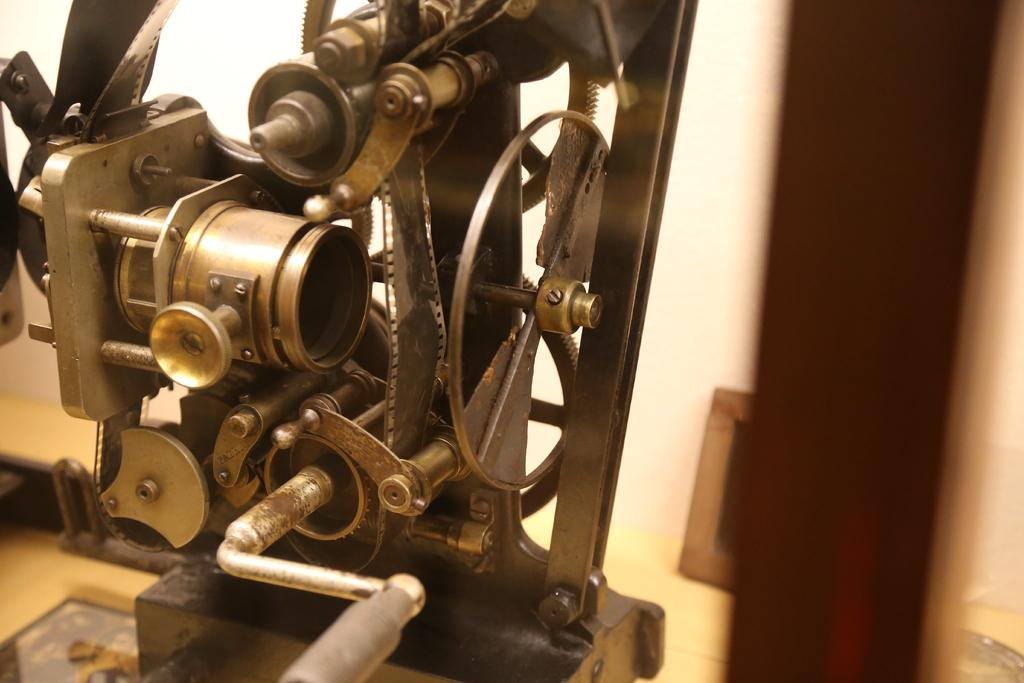What type of movie projector is in the image? There is a vintage reel to reel movie projector in the image. What is inside the projector? The projector has a reel, a wheel, and a handle inside, along with other visible parts. What is the condition of the background in the image? The background of the image is blurred. Reasoning: Let' Let's think step by step in order to produce the conversation. We start by identifying the main subject of the image, which is the vintage reel to reel movie projector. Then, we describe the specific features of the projector, including the reel, wheel, handle, and other visible parts. Finally, we mention the condition of the background, which is blurred. Each question is designed to elicit a specific detail about the image that is known from the provided facts. Absurd Question/Answer: What language is being spoken by the furniture in the image? There is no furniture present in the image, and therefore it cannot speak any language. 